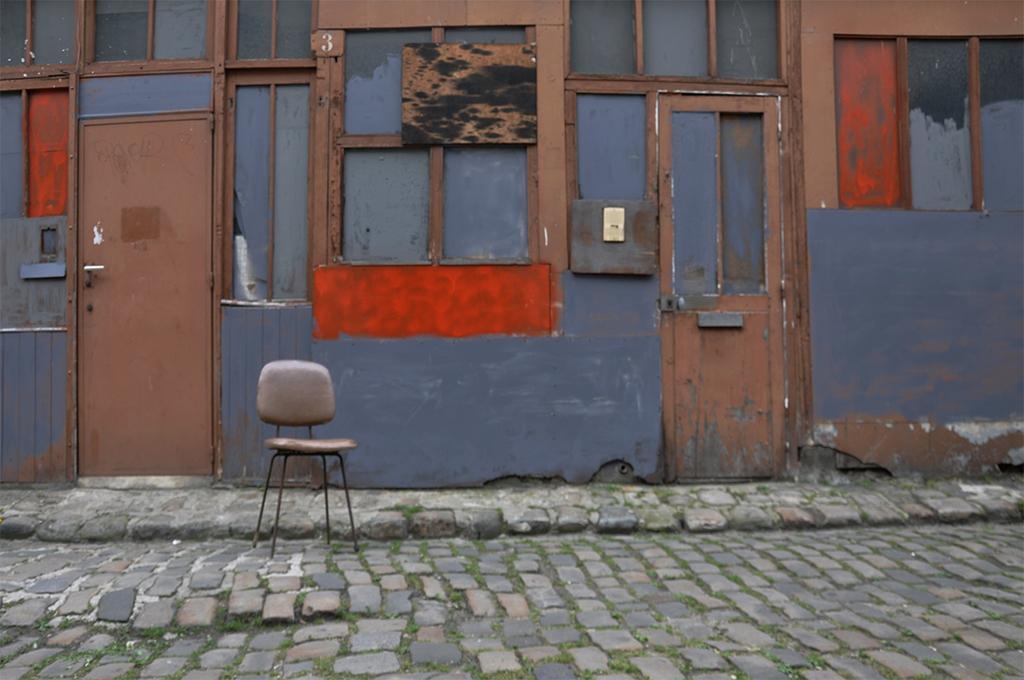Can you describe this image briefly? In the center of the image we can see windows and doors to the building. At the bottom of the image we can see chair on the road. 